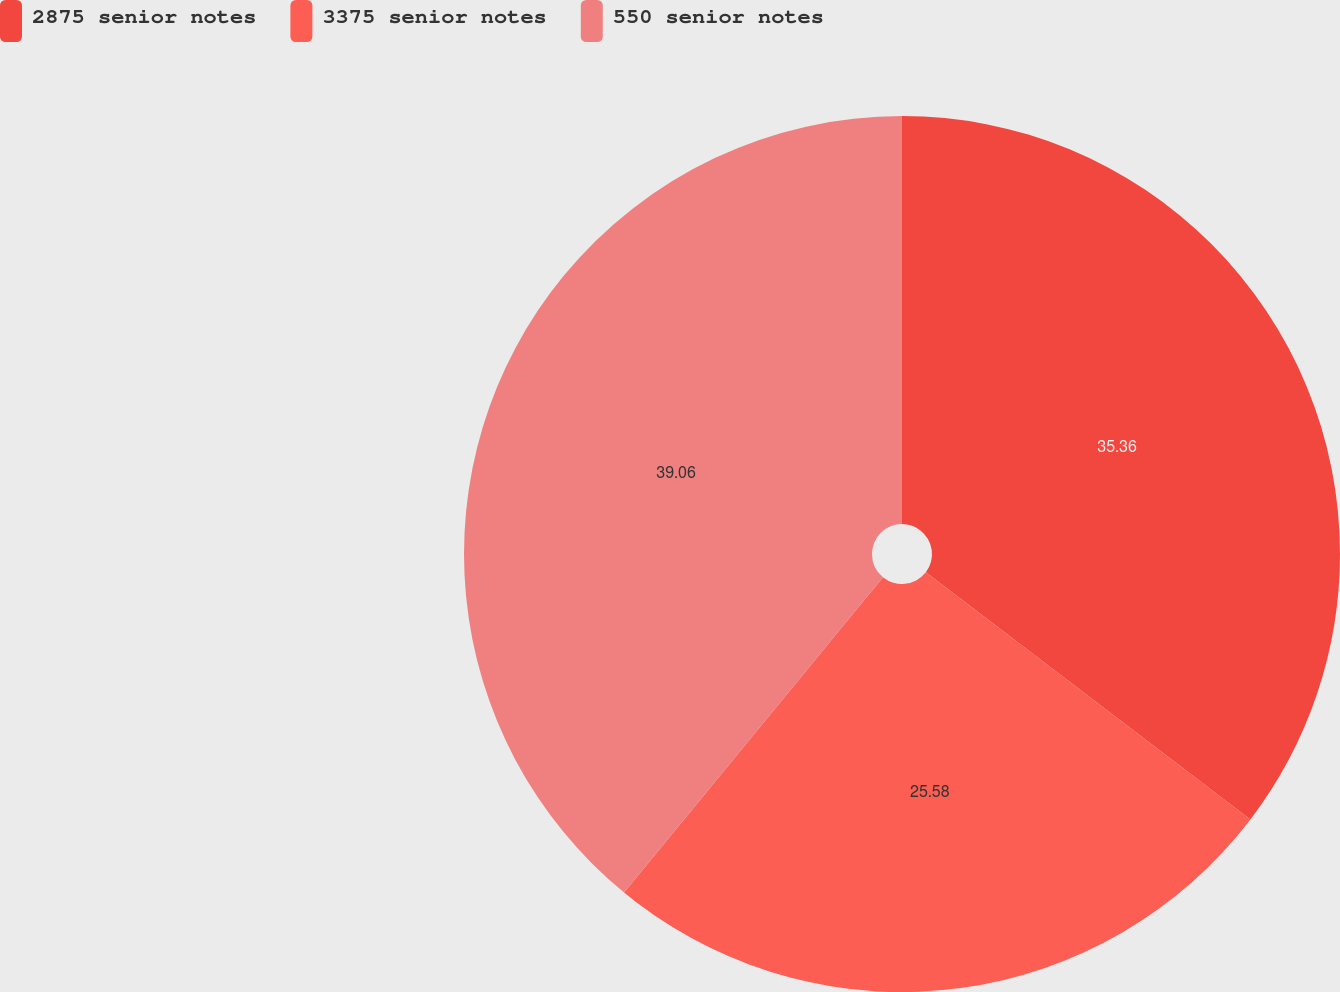<chart> <loc_0><loc_0><loc_500><loc_500><pie_chart><fcel>2875 senior notes<fcel>3375 senior notes<fcel>550 senior notes<nl><fcel>35.36%<fcel>25.58%<fcel>39.06%<nl></chart> 